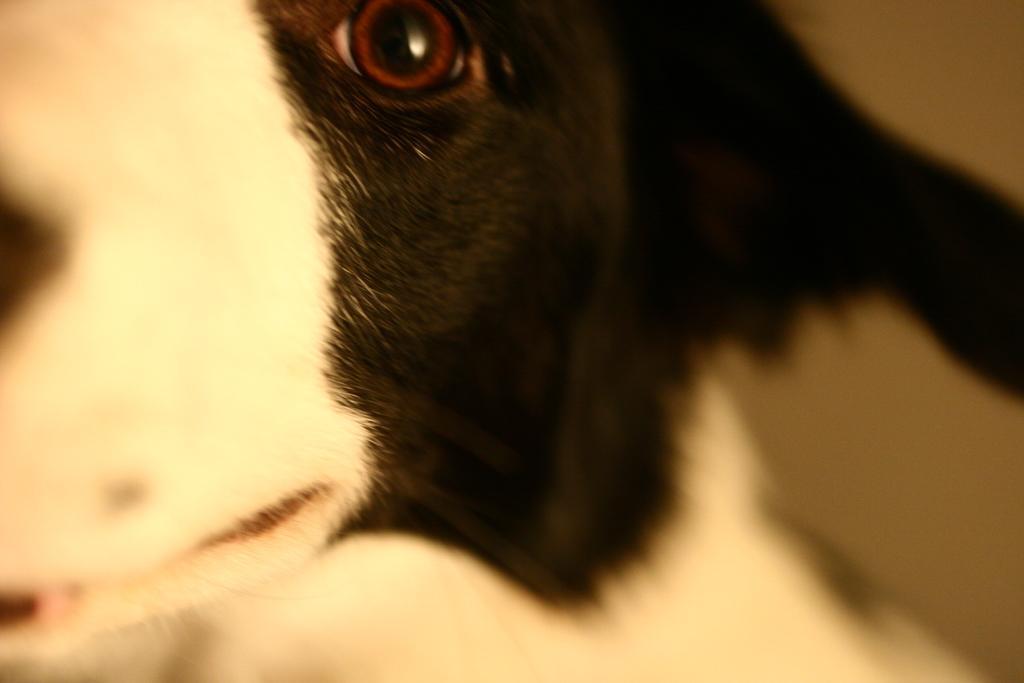Could you give a brief overview of what you see in this image? In this image we can see a dog. 